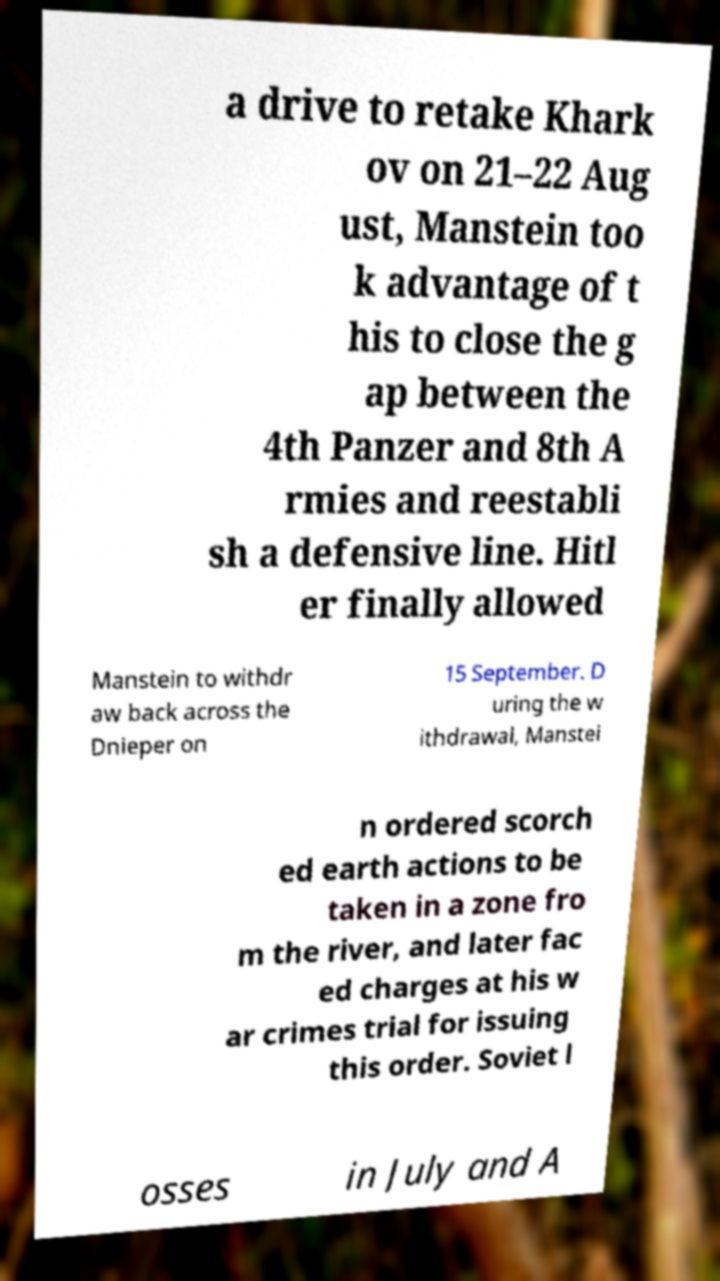Please identify and transcribe the text found in this image. a drive to retake Khark ov on 21–22 Aug ust, Manstein too k advantage of t his to close the g ap between the 4th Panzer and 8th A rmies and reestabli sh a defensive line. Hitl er finally allowed Manstein to withdr aw back across the Dnieper on 15 September. D uring the w ithdrawal, Manstei n ordered scorch ed earth actions to be taken in a zone fro m the river, and later fac ed charges at his w ar crimes trial for issuing this order. Soviet l osses in July and A 